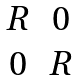<formula> <loc_0><loc_0><loc_500><loc_500>\begin{matrix} R & 0 \\ 0 & R \\ \end{matrix}</formula> 